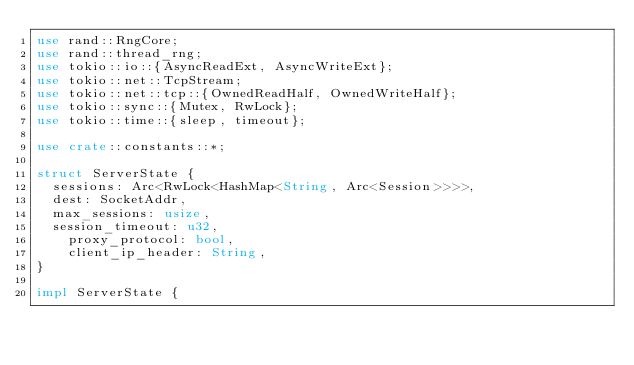<code> <loc_0><loc_0><loc_500><loc_500><_Rust_>use rand::RngCore;
use rand::thread_rng;
use tokio::io::{AsyncReadExt, AsyncWriteExt};
use tokio::net::TcpStream;
use tokio::net::tcp::{OwnedReadHalf, OwnedWriteHalf};
use tokio::sync::{Mutex, RwLock};
use tokio::time::{sleep, timeout};

use crate::constants::*;

struct ServerState {
	sessions: Arc<RwLock<HashMap<String, Arc<Session>>>>,
	dest: SocketAddr,
	max_sessions: usize,
	session_timeout: u32,
    proxy_protocol: bool,
    client_ip_header: String,
}

impl ServerState {</code> 